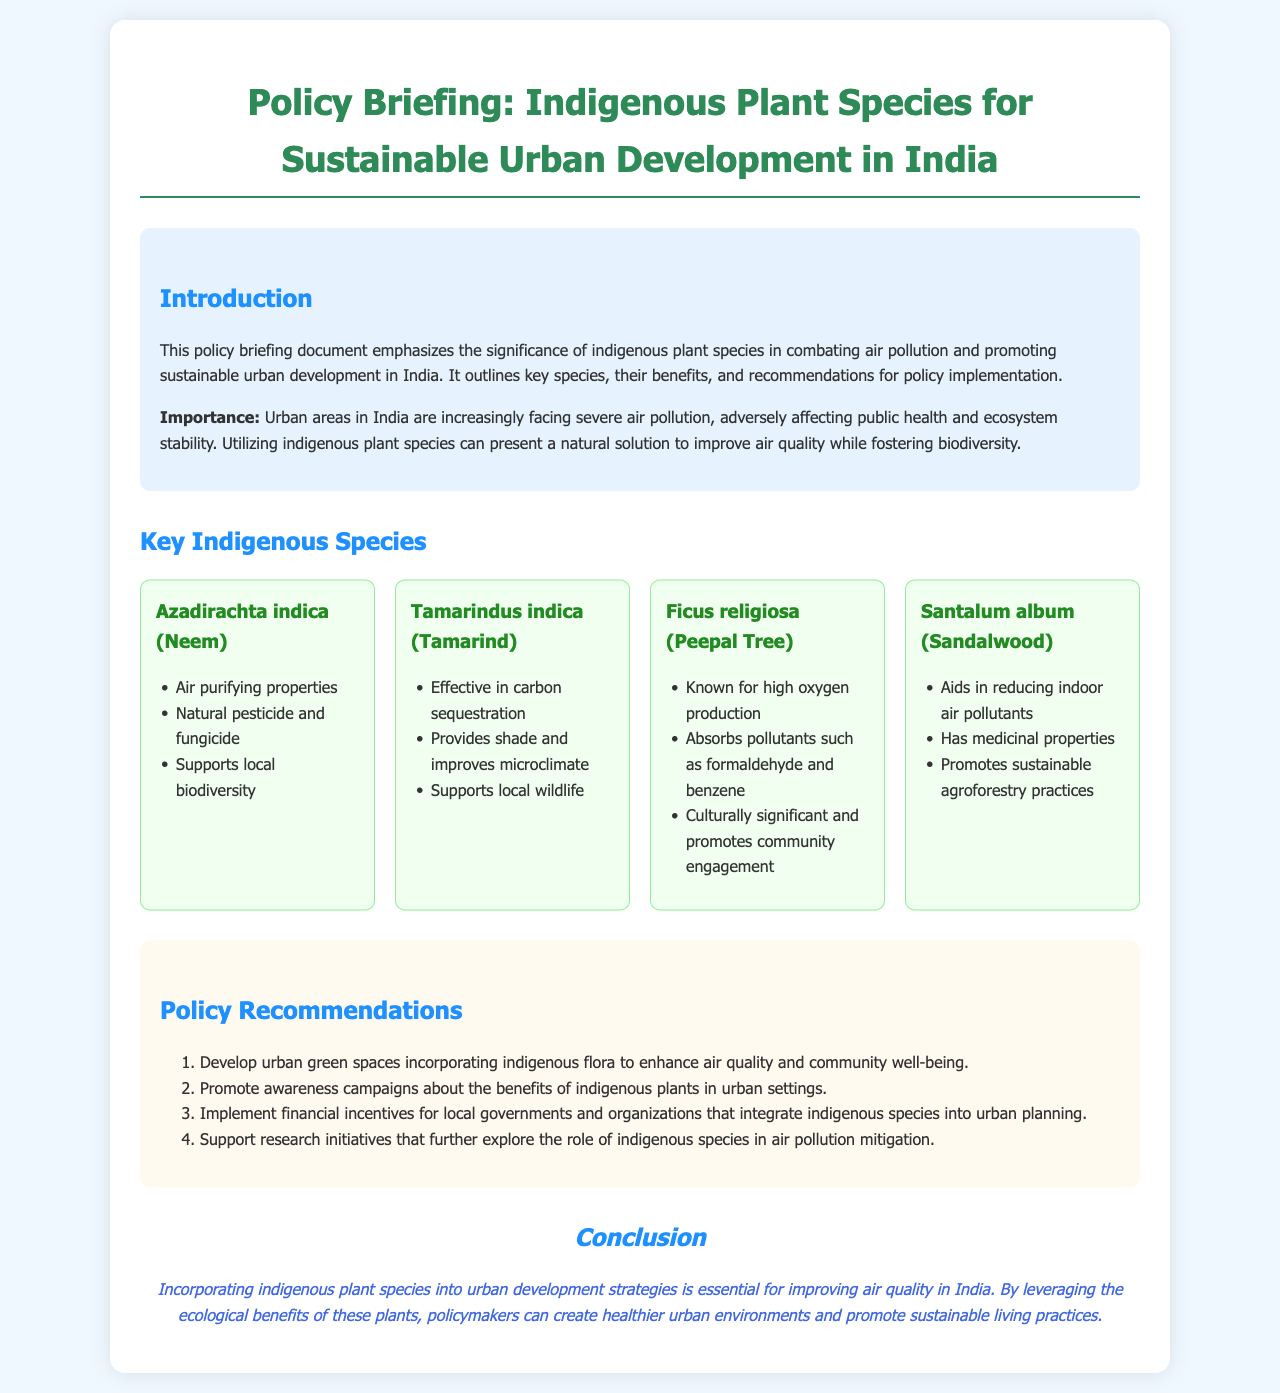What is the title of the document? The title of the document is indicated at the top, which describes the subject and purpose of the manual.
Answer: Policy Briefing: Indigenous Plant Species for Sustainable Urban Development in India How many key indigenous species are mentioned? The document lists four specific indigenous species that are highlighted for their benefits, which can be counted.
Answer: Four Which species is known for high oxygen production? The species that is specifically noted for its high oxygen production is listed under the 'Key Indigenous Species' section.
Answer: Ficus religiosa (Peepal Tree) What is one of the recommendations for policy implementation? The recommendations are listed in an ordered format; one of them refers to enhancing urban green spaces incorporating indigenous flora.
Answer: Develop urban green spaces What is the primary benefit mentioned for Azadirachta indica? The primary benefit is mentioned in the list of attributes for this species, specifically relating to its air purifying properties.
Answer: Air purifying properties What type of document is this? The document is categorized based on its purpose and structure, indicating it serves as a policy briefing.
Answer: Policy Briefing Document 